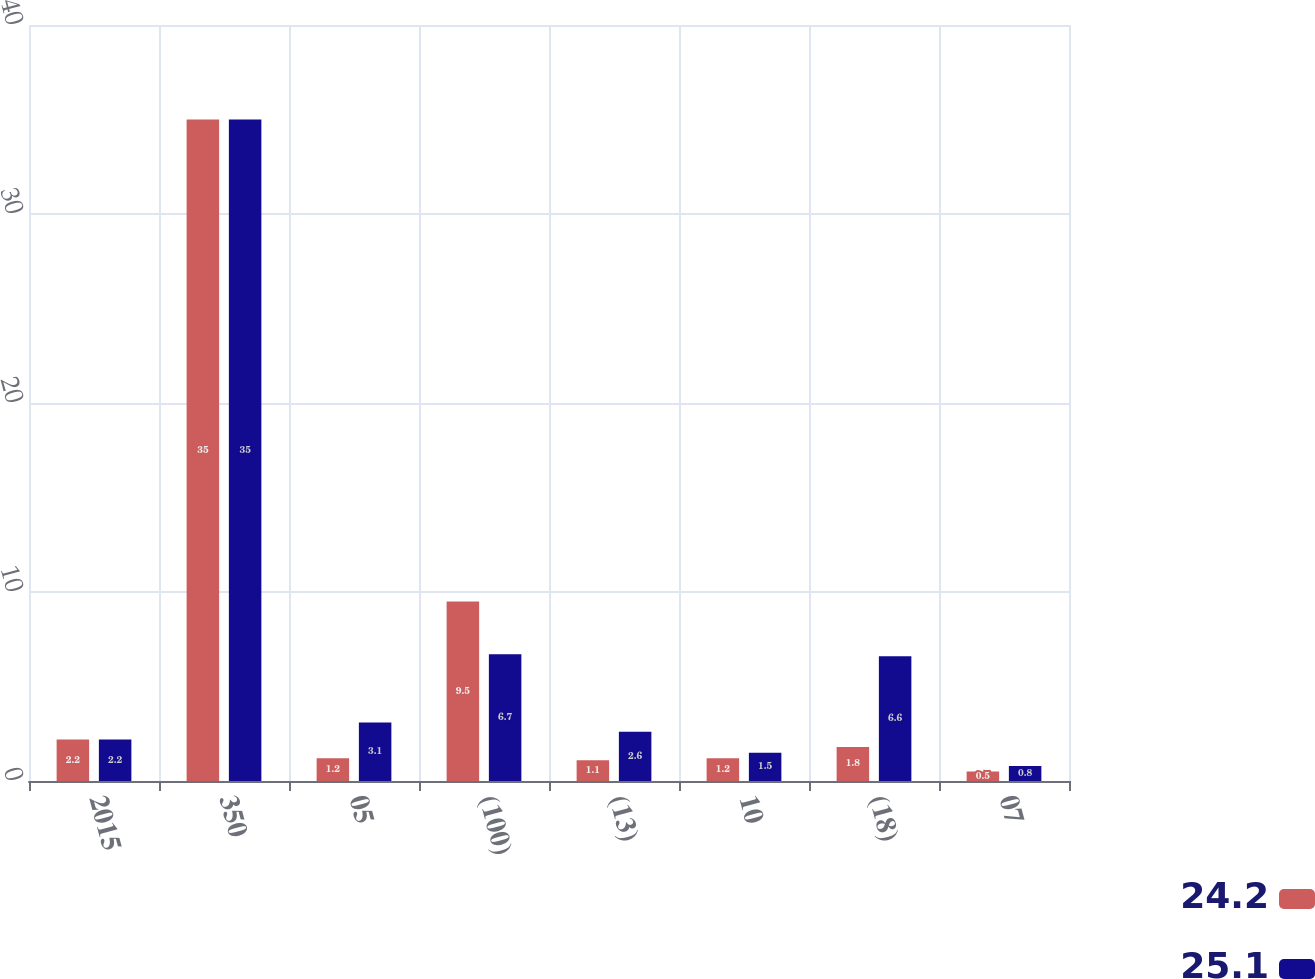Convert chart. <chart><loc_0><loc_0><loc_500><loc_500><stacked_bar_chart><ecel><fcel>2015<fcel>350<fcel>05<fcel>(100)<fcel>(13)<fcel>10<fcel>(18)<fcel>07<nl><fcel>24.2<fcel>2.2<fcel>35<fcel>1.2<fcel>9.5<fcel>1.1<fcel>1.2<fcel>1.8<fcel>0.5<nl><fcel>25.1<fcel>2.2<fcel>35<fcel>3.1<fcel>6.7<fcel>2.6<fcel>1.5<fcel>6.6<fcel>0.8<nl></chart> 